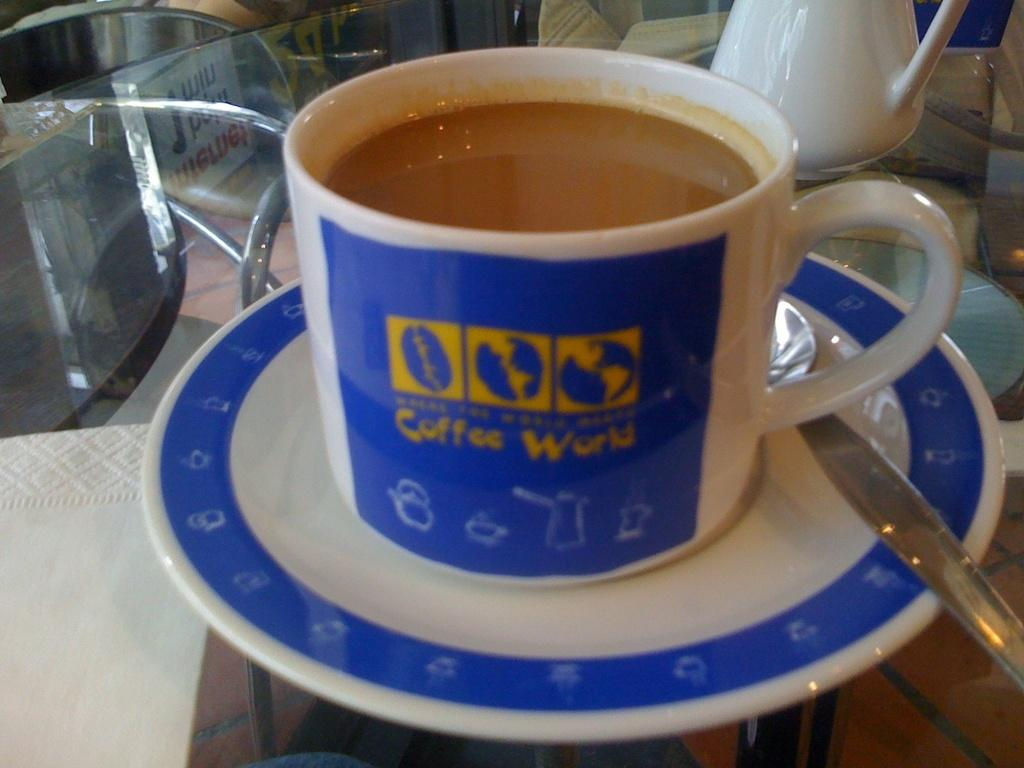What is present in the image that can hold liquid? There is a cup in the image that can hold liquid. What is inside the cup? There is liquid in the cup. What accompanies the cup in the image? There is a saucer and a spoon in the image. What is the object on the glass table? The object on the glass table is not specified, but it could be the cup, saucer, or spoon. What type of furniture is visible in the image? There are chairs in the image. What is the chance of the cup being destroyed in the image? There is no indication of the cup being destroyed or any chance of destruction in the image. 